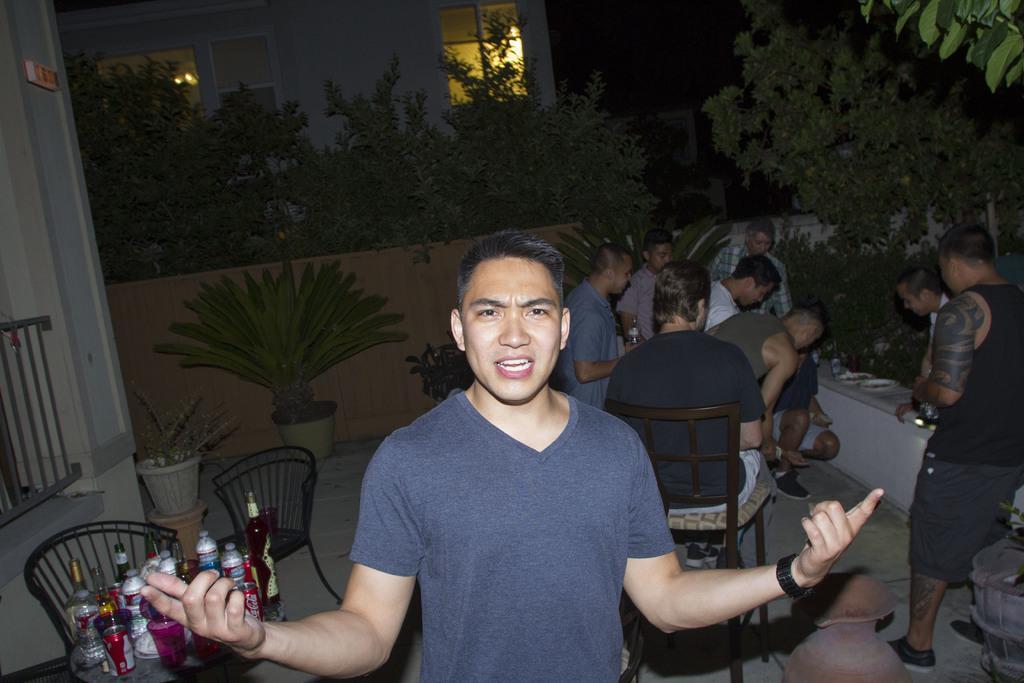In one or two sentences, can you explain what this image depicts? In the center of the image we can see one person standing and he is smiling, which we can see on his face. On the bottom left side of the image, there is a table. On the table, we can see the bottles. In the background there is a wall, one sign board, fence, windows, lights, trees, plant pots, plants, chairs, plate, one pot, one person standing, few people are sitting, few people are holding bottles and a few other objects. 